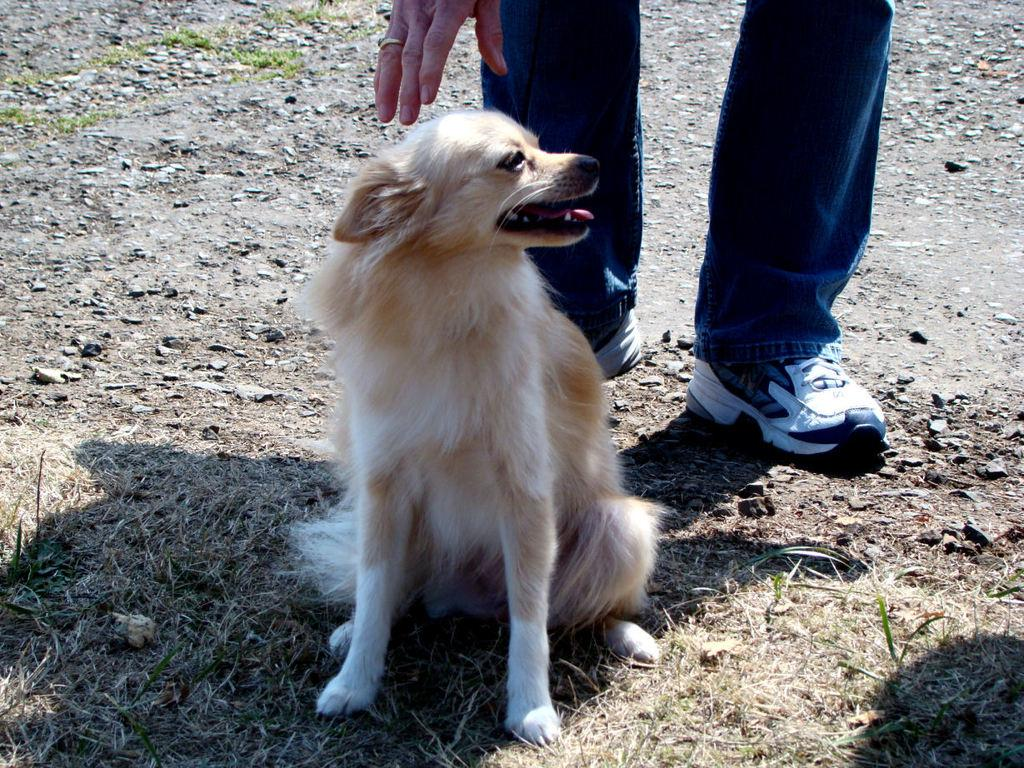What type of animal is in the image? There is a dog in the image. Who else is present in the image? There is a person in the image. What accessory is the person wearing on their finger? The person is wearing a ring on their finger. What type of clothing is the person wearing on their lower body? The person is wearing blue jeans. What type of footwear is the person wearing? The person is wearing shoes. What type of locket is the person holding in the image? There is no locket present in the image. What company is responsible for the shoes the person is wearing? The image does not provide information about the brand or company of the shoes. 